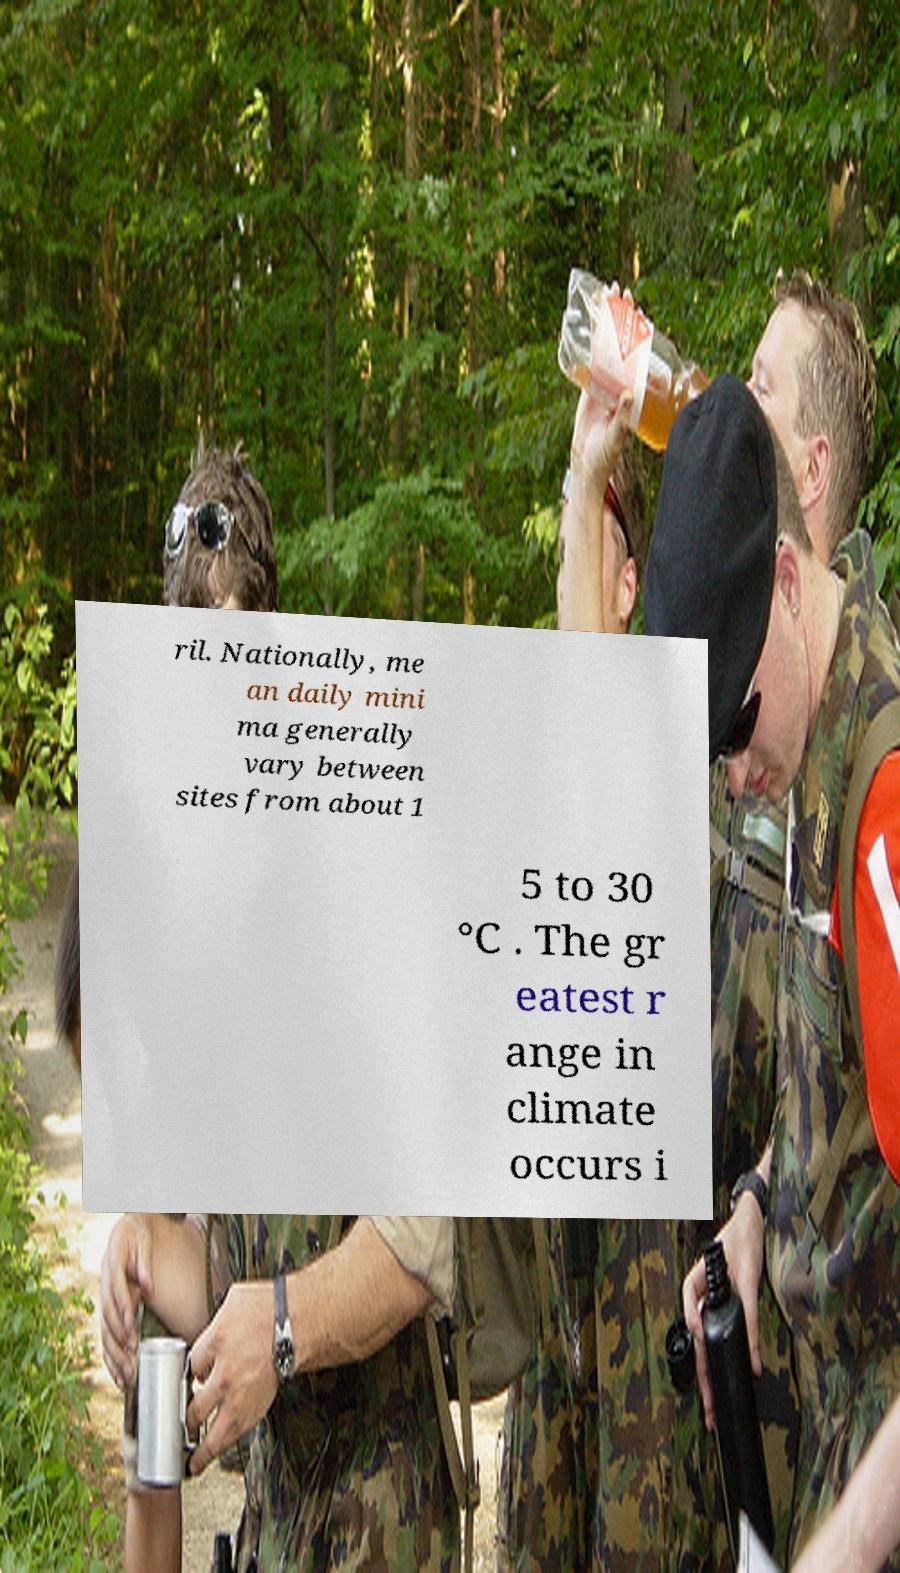Could you extract and type out the text from this image? ril. Nationally, me an daily mini ma generally vary between sites from about 1 5 to 30 °C . The gr eatest r ange in climate occurs i 